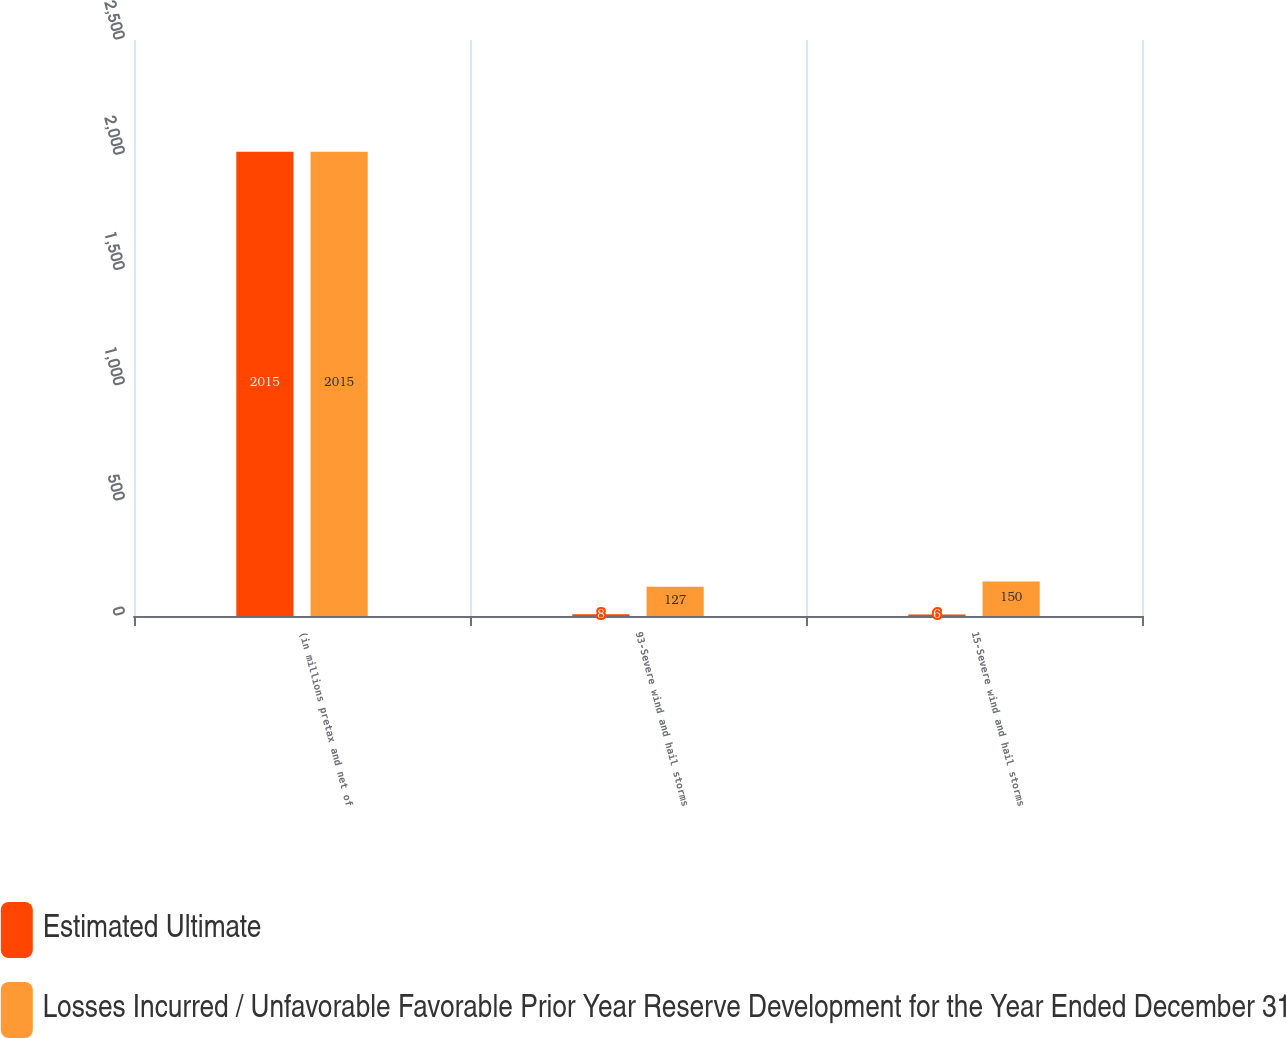Convert chart to OTSL. <chart><loc_0><loc_0><loc_500><loc_500><stacked_bar_chart><ecel><fcel>(in millions pretax and net of<fcel>93-Severe wind and hail storms<fcel>15-Severe wind and hail storms<nl><fcel>Estimated Ultimate<fcel>2015<fcel>8<fcel>6<nl><fcel>Losses Incurred / Unfavorable Favorable Prior Year Reserve Development for the Year Ended December 31<fcel>2015<fcel>127<fcel>150<nl></chart> 